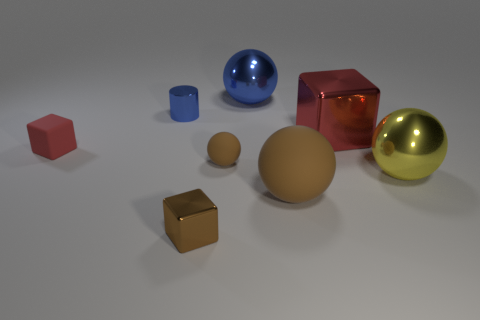Add 1 blocks. How many objects exist? 9 Subtract all cylinders. How many objects are left? 7 Subtract 1 yellow spheres. How many objects are left? 7 Subtract all small red matte things. Subtract all cylinders. How many objects are left? 6 Add 5 yellow things. How many yellow things are left? 6 Add 5 tiny yellow shiny balls. How many tiny yellow shiny balls exist? 5 